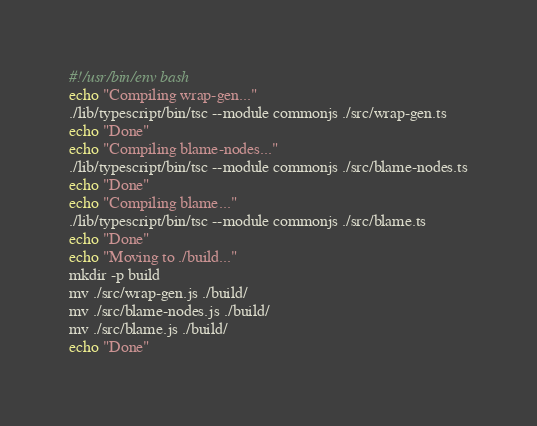<code> <loc_0><loc_0><loc_500><loc_500><_Bash_>#!/usr/bin/env bash
echo "Compiling wrap-gen..."
./lib/typescript/bin/tsc --module commonjs ./src/wrap-gen.ts
echo "Done"
echo "Compiling blame-nodes..."
./lib/typescript/bin/tsc --module commonjs ./src/blame-nodes.ts
echo "Done"
echo "Compiling blame..."
./lib/typescript/bin/tsc --module commonjs ./src/blame.ts
echo "Done"
echo "Moving to ./build..."
mkdir -p build
mv ./src/wrap-gen.js ./build/
mv ./src/blame-nodes.js ./build/
mv ./src/blame.js ./build/
echo "Done"
</code> 